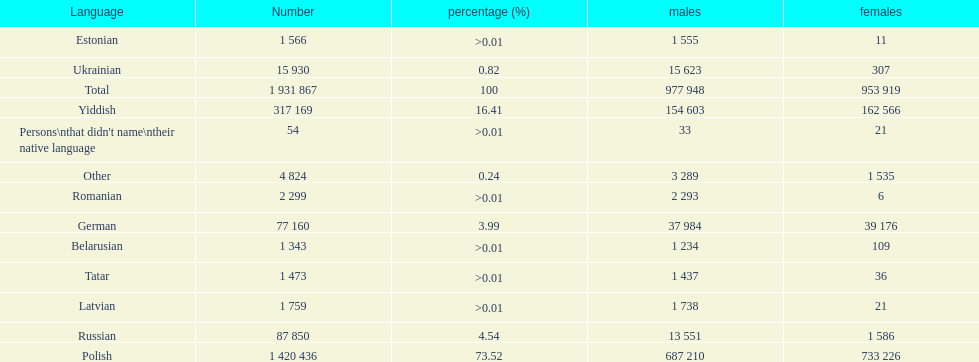What was the top language from the one's whose percentage was >0.01 Romanian. 